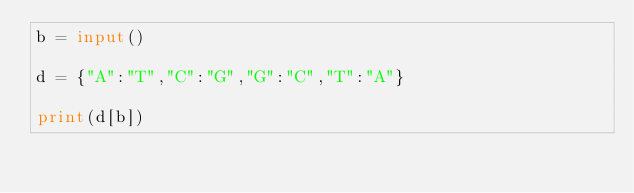<code> <loc_0><loc_0><loc_500><loc_500><_Python_>b = input()

d = {"A":"T","C":"G","G":"C","T":"A"}

print(d[b])</code> 